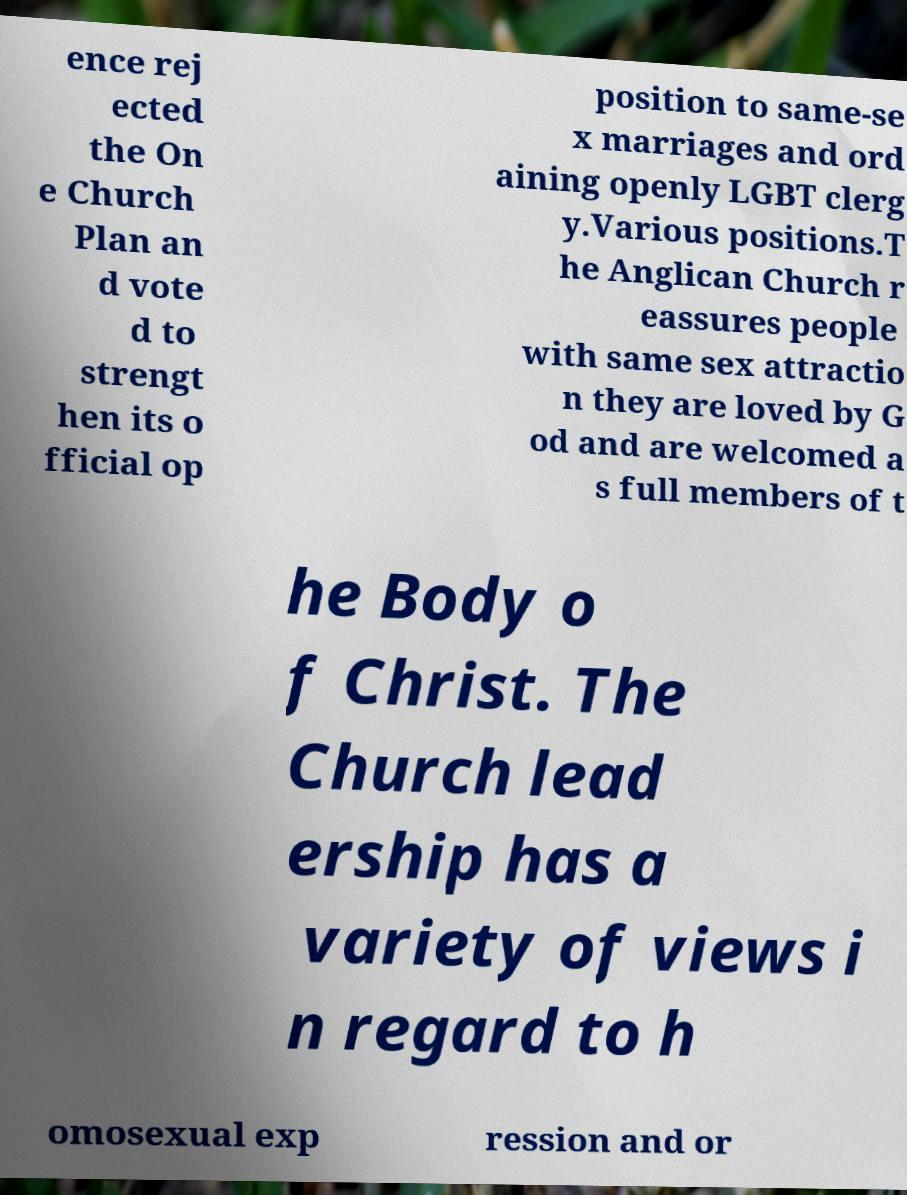I need the written content from this picture converted into text. Can you do that? ence rej ected the On e Church Plan an d vote d to strengt hen its o fficial op position to same-se x marriages and ord aining openly LGBT clerg y.Various positions.T he Anglican Church r eassures people with same sex attractio n they are loved by G od and are welcomed a s full members of t he Body o f Christ. The Church lead ership has a variety of views i n regard to h omosexual exp ression and or 